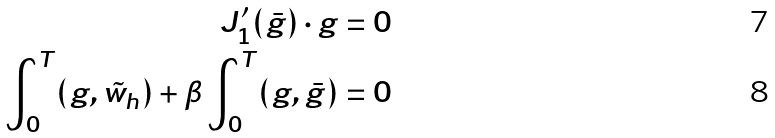<formula> <loc_0><loc_0><loc_500><loc_500>J _ { 1 } ^ { \prime } ( \bar { g } ) \cdot g & = 0 \\ \int _ { 0 } ^ { T } ( g , \tilde { w } _ { h } ) + \beta \int _ { 0 } ^ { T } ( g , \bar { g } ) & = 0</formula> 